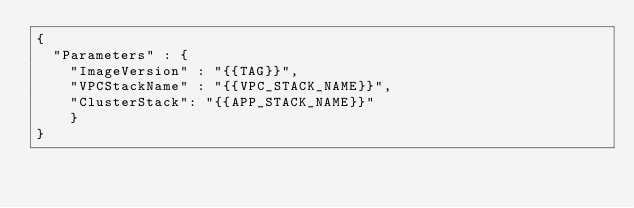Convert code to text. <code><loc_0><loc_0><loc_500><loc_500><_YAML_>{
  "Parameters" : {
    "ImageVersion" : "{{TAG}}",
    "VPCStackName" : "{{VPC_STACK_NAME}}",
    "ClusterStack": "{{APP_STACK_NAME}}"
    } 
}</code> 